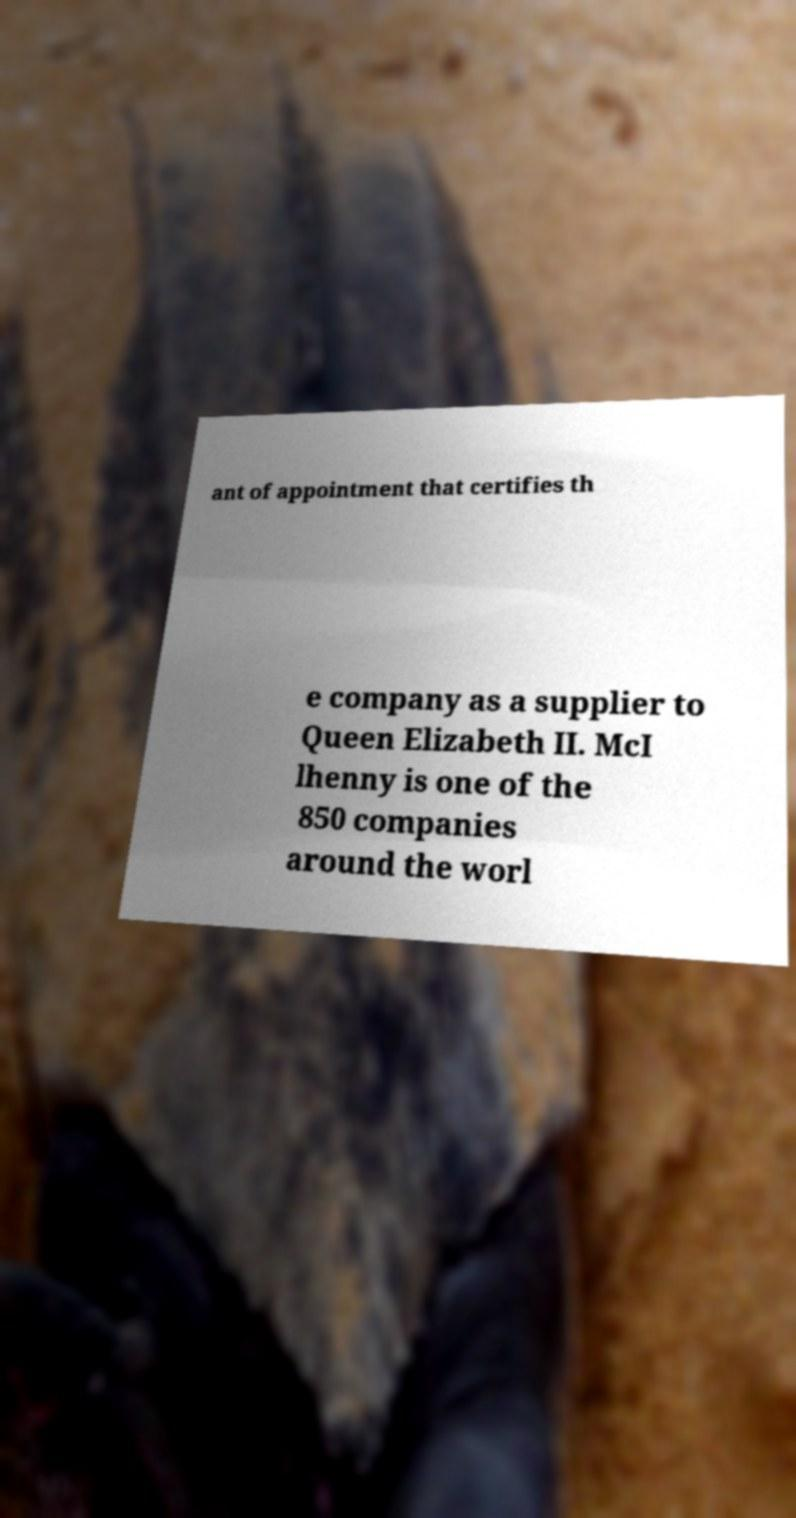Can you accurately transcribe the text from the provided image for me? ant of appointment that certifies th e company as a supplier to Queen Elizabeth II. McI lhenny is one of the 850 companies around the worl 